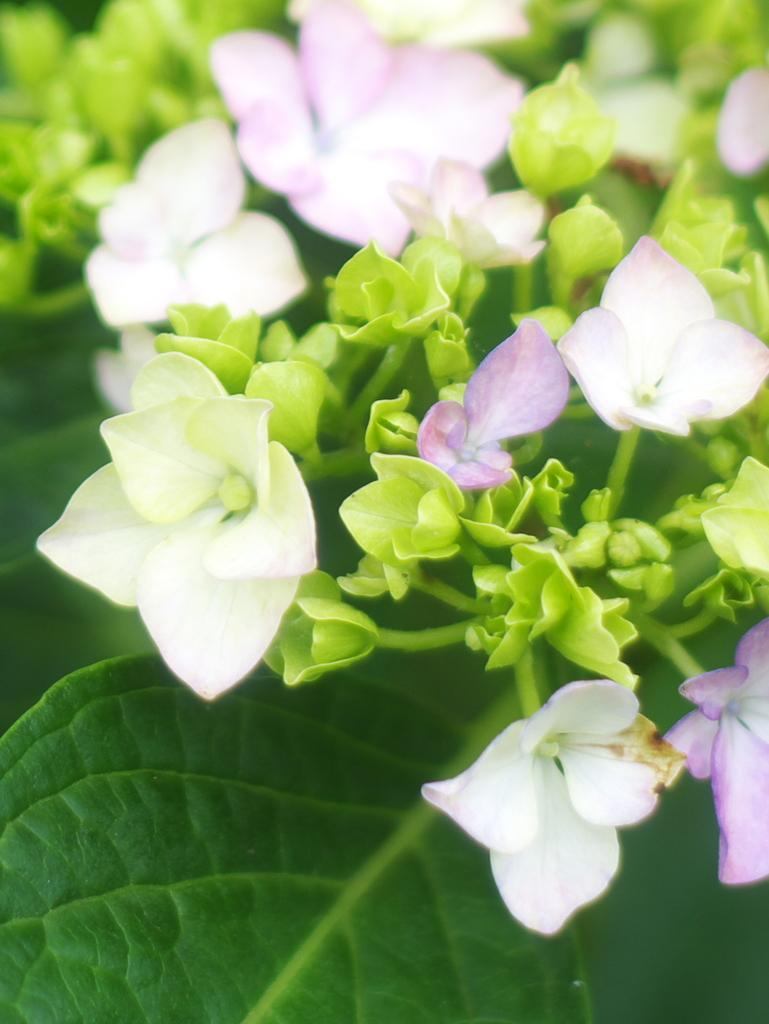What type of plants can be seen in the image? There are flowers and leaves in the image. Can you describe the appearance of the flowers? Unfortunately, the specific appearance of the flowers cannot be determined from the provided facts. Are there any other elements present in the image besides the flowers and leaves? No additional elements are mentioned in the provided facts. What type of meal is being prepared in the image? There is no indication of a meal being prepared in the image, as it only features flowers and leaves. 